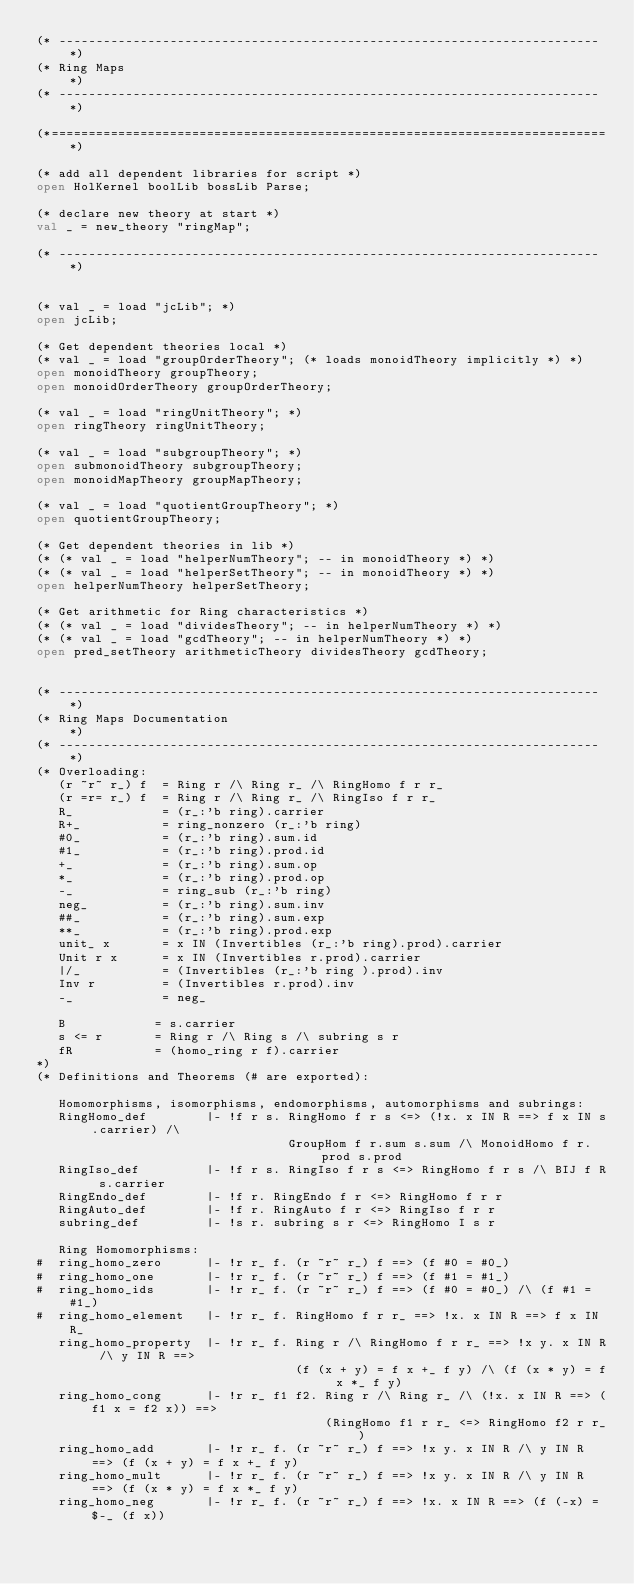<code> <loc_0><loc_0><loc_500><loc_500><_SML_>(* ------------------------------------------------------------------------- *)
(* Ring Maps                                                                 *)
(* ------------------------------------------------------------------------- *)

(*===========================================================================*)

(* add all dependent libraries for script *)
open HolKernel boolLib bossLib Parse;

(* declare new theory at start *)
val _ = new_theory "ringMap";

(* ------------------------------------------------------------------------- *)


(* val _ = load "jcLib"; *)
open jcLib;

(* Get dependent theories local *)
(* val _ = load "groupOrderTheory"; (* loads monoidTheory implicitly *) *)
open monoidTheory groupTheory;
open monoidOrderTheory groupOrderTheory;

(* val _ = load "ringUnitTheory"; *)
open ringTheory ringUnitTheory;

(* val _ = load "subgroupTheory"; *)
open submonoidTheory subgroupTheory;
open monoidMapTheory groupMapTheory;

(* val _ = load "quotientGroupTheory"; *)
open quotientGroupTheory;

(* Get dependent theories in lib *)
(* (* val _ = load "helperNumTheory"; -- in monoidTheory *) *)
(* (* val _ = load "helperSetTheory"; -- in monoidTheory *) *)
open helperNumTheory helperSetTheory;

(* Get arithmetic for Ring characteristics *)
(* (* val _ = load "dividesTheory"; -- in helperNumTheory *) *)
(* (* val _ = load "gcdTheory"; -- in helperNumTheory *) *)
open pred_setTheory arithmeticTheory dividesTheory gcdTheory;


(* ------------------------------------------------------------------------- *)
(* Ring Maps Documentation                                                   *)
(* ------------------------------------------------------------------------- *)
(* Overloading:
   (r ~r~ r_) f  = Ring r /\ Ring r_ /\ RingHomo f r r_
   (r =r= r_) f  = Ring r /\ Ring r_ /\ RingIso f r r_
   R_            = (r_:'b ring).carrier
   R+_           = ring_nonzero (r_:'b ring)
   #0_           = (r_:'b ring).sum.id
   #1_           = (r_:'b ring).prod.id
   +_            = (r_:'b ring).sum.op
   *_            = (r_:'b ring).prod.op
   -_            = ring_sub (r_:'b ring)
   neg_          = (r_:'b ring).sum.inv
   ##_           = (r_:'b ring).sum.exp
   **_           = (r_:'b ring).prod.exp
   unit_ x       = x IN (Invertibles (r_:'b ring).prod).carrier
   Unit r x      = x IN (Invertibles r.prod).carrier
   |/_           = (Invertibles (r_:'b ring ).prod).inv
   Inv r         = (Invertibles r.prod).inv
   -_            = neg_

   B            = s.carrier
   s <= r       = Ring r /\ Ring s /\ subring s r
   fR           = (homo_ring r f).carrier
*)
(* Definitions and Theorems (# are exported):

   Homomorphisms, isomorphisms, endomorphisms, automorphisms and subrings:
   RingHomo_def        |- !f r s. RingHomo f r s <=> (!x. x IN R ==> f x IN s.carrier) /\
                                  GroupHom f r.sum s.sum /\ MonoidHomo f r.prod s.prod
   RingIso_def         |- !f r s. RingIso f r s <=> RingHomo f r s /\ BIJ f R s.carrier
   RingEndo_def        |- !f r. RingEndo f r <=> RingHomo f r r
   RingAuto_def        |- !f r. RingAuto f r <=> RingIso f r r
   subring_def         |- !s r. subring s r <=> RingHomo I s r

   Ring Homomorphisms:
#  ring_homo_zero      |- !r r_ f. (r ~r~ r_) f ==> (f #0 = #0_)
#  ring_homo_one       |- !r r_ f. (r ~r~ r_) f ==> (f #1 = #1_)
#  ring_homo_ids       |- !r r_ f. (r ~r~ r_) f ==> (f #0 = #0_) /\ (f #1 = #1_)
#  ring_homo_element   |- !r r_ f. RingHomo f r r_ ==> !x. x IN R ==> f x IN R_
   ring_homo_property  |- !r r_ f. Ring r /\ RingHomo f r r_ ==> !x y. x IN R /\ y IN R ==>
                                   (f (x + y) = f x +_ f y) /\ (f (x * y) = f x *_ f y)
   ring_homo_cong      |- !r r_ f1 f2. Ring r /\ Ring r_ /\ (!x. x IN R ==> (f1 x = f2 x)) ==>
                                       (RingHomo f1 r r_ <=> RingHomo f2 r r_)
   ring_homo_add       |- !r r_ f. (r ~r~ r_) f ==> !x y. x IN R /\ y IN R ==> (f (x + y) = f x +_ f y)
   ring_homo_mult      |- !r r_ f. (r ~r~ r_) f ==> !x y. x IN R /\ y IN R ==> (f (x * y) = f x *_ f y)
   ring_homo_neg       |- !r r_ f. (r ~r~ r_) f ==> !x. x IN R ==> (f (-x) = $-_ (f x))</code> 